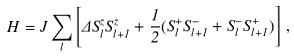Convert formula to latex. <formula><loc_0><loc_0><loc_500><loc_500>H = J \sum _ { l } \left [ \Delta S _ { l } ^ { z } S _ { l + 1 } ^ { z } + \frac { 1 } { 2 } ( S _ { l } ^ { + } S _ { l + 1 } ^ { - } + S _ { l } ^ { - } S _ { l + 1 } ^ { + } ) \right ] \, ,</formula> 